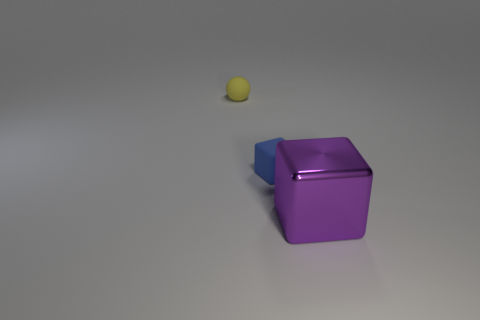Add 2 small yellow things. How many objects exist? 5 Subtract all cubes. How many objects are left? 1 Subtract 0 green spheres. How many objects are left? 3 Subtract all yellow matte spheres. Subtract all matte balls. How many objects are left? 1 Add 1 matte blocks. How many matte blocks are left? 2 Add 2 big purple cubes. How many big purple cubes exist? 3 